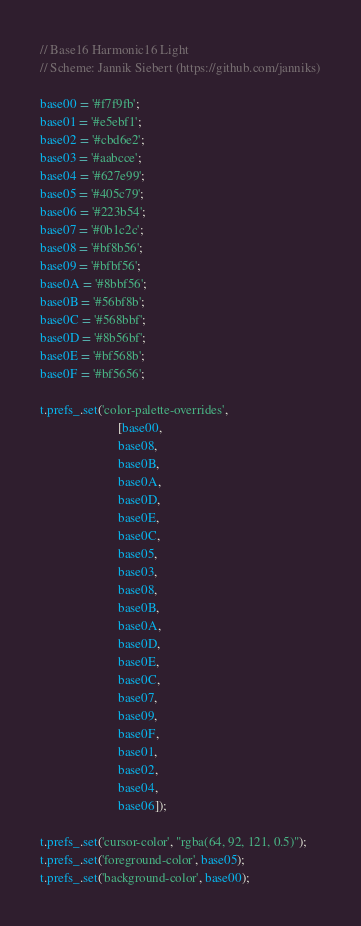Convert code to text. <code><loc_0><loc_0><loc_500><loc_500><_JavaScript_>// Base16 Harmonic16 Light
// Scheme: Jannik Siebert (https://github.com/janniks)

base00 = '#f7f9fb';
base01 = '#e5ebf1';
base02 = '#cbd6e2';
base03 = '#aabcce';
base04 = '#627e99';
base05 = '#405c79';
base06 = '#223b54';
base07 = '#0b1c2c';
base08 = '#bf8b56';
base09 = '#bfbf56';
base0A = '#8bbf56';
base0B = '#56bf8b';
base0C = '#568bbf';
base0D = '#8b56bf';
base0E = '#bf568b';
base0F = '#bf5656';

t.prefs_.set('color-palette-overrides', 
                        [base00,
                        base08,
                        base0B,
                        base0A,
                        base0D,
                        base0E,
                        base0C,
                        base05,
                        base03,
                        base08,
                        base0B,
                        base0A,
                        base0D,
                        base0E,
                        base0C,
                        base07,
                        base09,
                        base0F,
                        base01,
                        base02,
                        base04,
                        base06]);

t.prefs_.set('cursor-color', "rgba(64, 92, 121, 0.5)");
t.prefs_.set('foreground-color', base05);
t.prefs_.set('background-color', base00);
</code> 